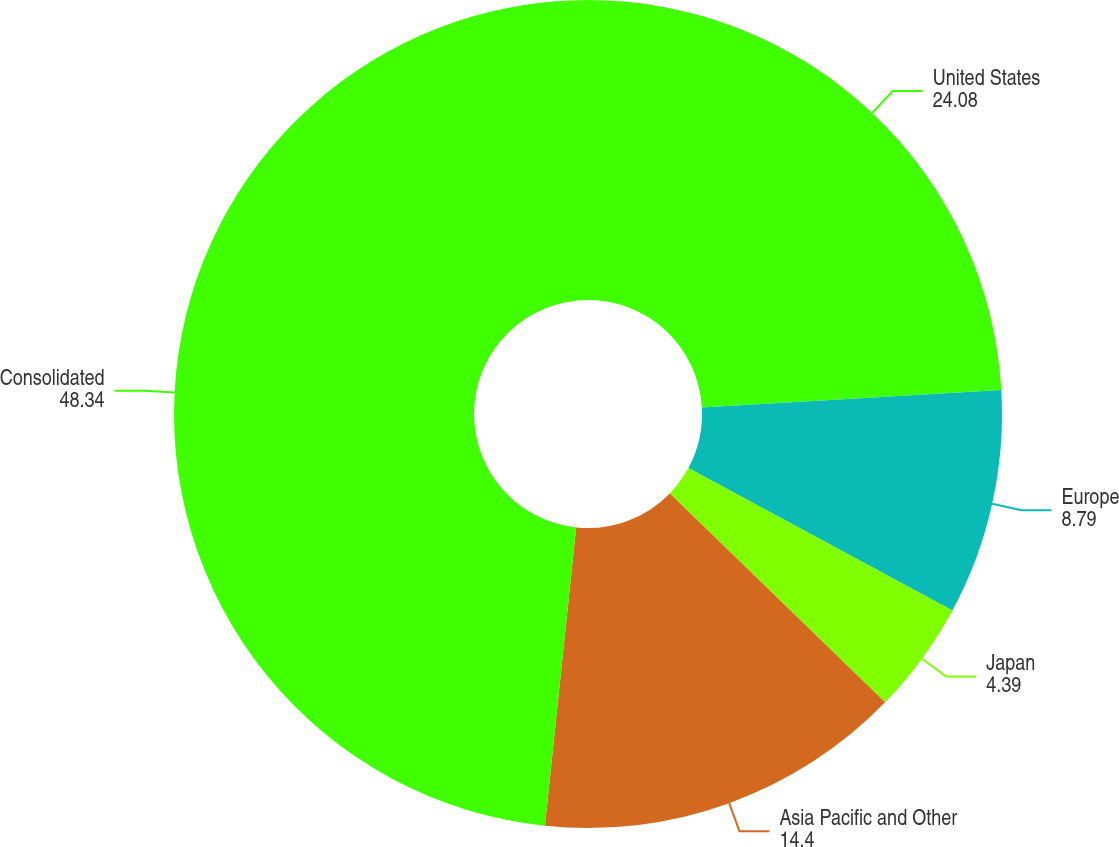<chart> <loc_0><loc_0><loc_500><loc_500><pie_chart><fcel>United States<fcel>Europe<fcel>Japan<fcel>Asia Pacific and Other<fcel>Consolidated<nl><fcel>24.08%<fcel>8.79%<fcel>4.39%<fcel>14.4%<fcel>48.34%<nl></chart> 